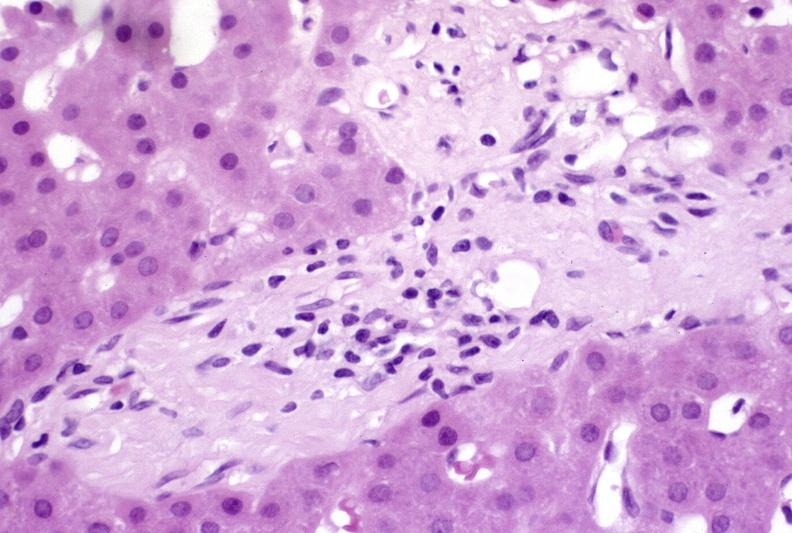what is present?
Answer the question using a single word or phrase. Liver 